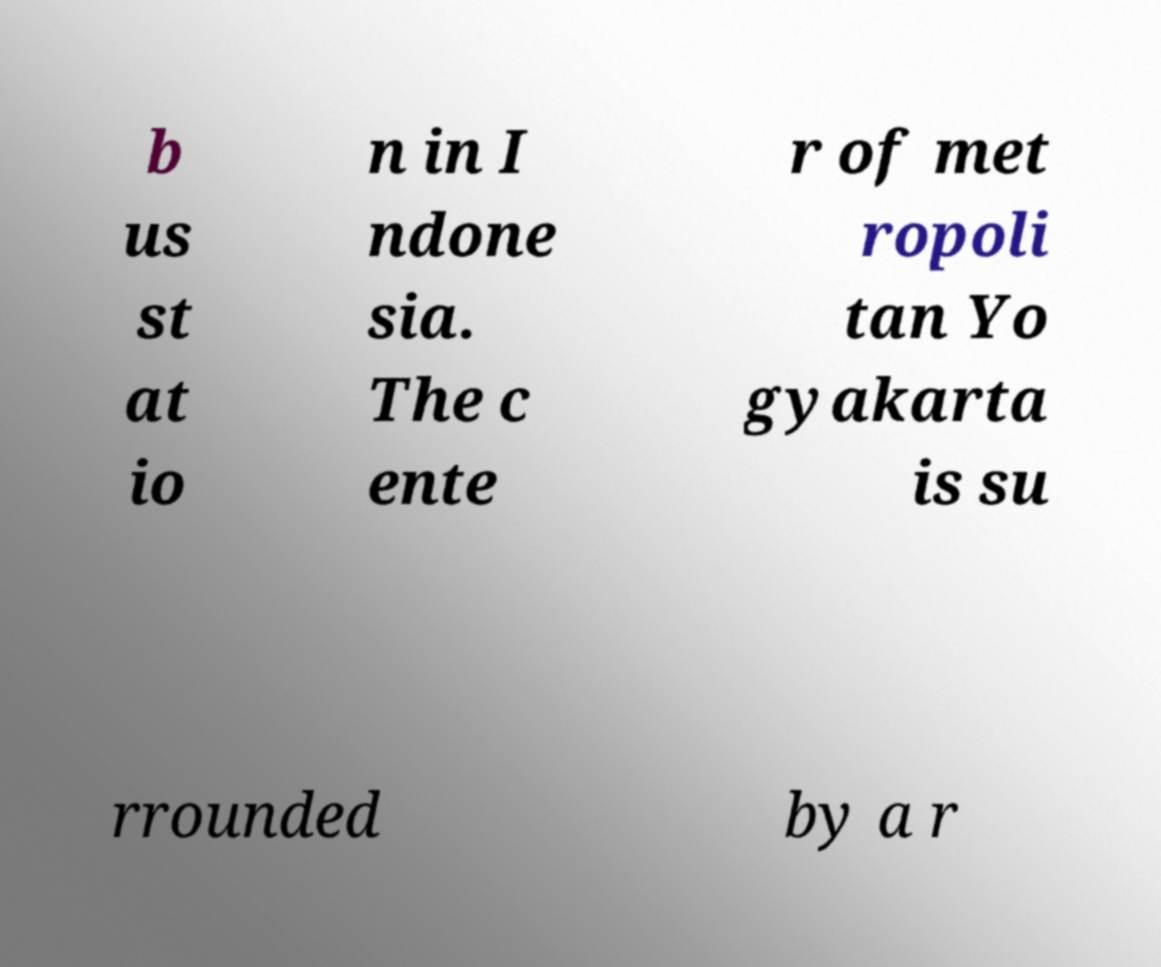Please read and relay the text visible in this image. What does it say? b us st at io n in I ndone sia. The c ente r of met ropoli tan Yo gyakarta is su rrounded by a r 